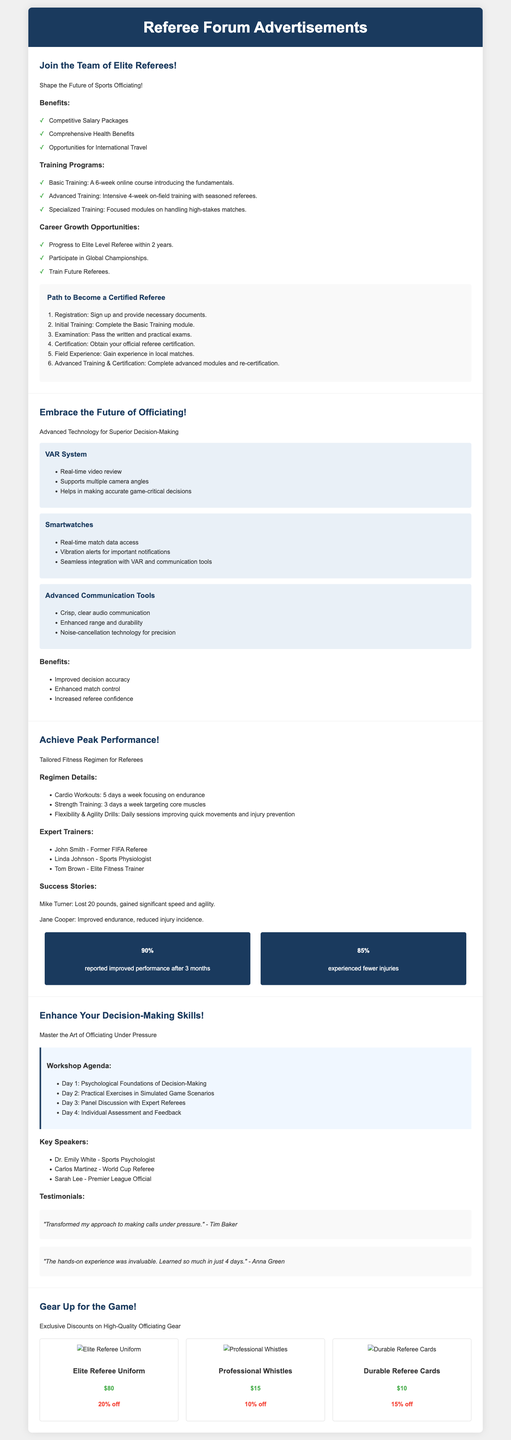what are the three benefits listed in the recruitment campaign? The benefits listed include Competitive Salary Packages, Comprehensive Health Benefits, and Opportunities for International Travel.
Answer: Competitive Salary Packages, Comprehensive Health Benefits, Opportunities for International Travel how long is the basic training course? The Basic Training course is a 6-week online course introducing the fundamentals.
Answer: 6 weeks what is the percentage of participants who reported improved performance after 3 months in the fitness program? The document states that 90% reported improved performance after 3 months.
Answer: 90% who is a key speaker at the decision-making workshop? One of the key speakers is Dr. Emily White, who is a Sports Psychologist.
Answer: Dr. Emily White what discount is offered on the Elite Referee Uniform? The advertisement specifies that the Elite Referee Uniform has a discount of 20%.
Answer: 20% off what is the total number of days for the workshop agenda? The workshop agenda spans 4 days, as specified in the document.
Answer: 4 days which technology helps in making accurate game-critical decisions? The VAR System helps in making accurate game-critical decisions.
Answer: VAR System who is the expert trainer with a background as a former FIFA Referee? The expert trainer with a background as a former FIFA Referee is John Smith.
Answer: John Smith 